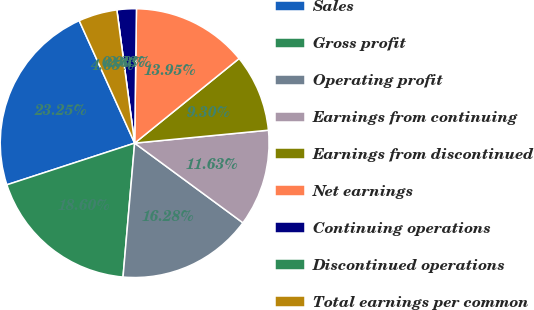<chart> <loc_0><loc_0><loc_500><loc_500><pie_chart><fcel>Sales<fcel>Gross profit<fcel>Operating profit<fcel>Earnings from continuing<fcel>Earnings from discontinued<fcel>Net earnings<fcel>Continuing operations<fcel>Discontinued operations<fcel>Total earnings per common<nl><fcel>23.25%<fcel>18.6%<fcel>16.28%<fcel>11.63%<fcel>9.3%<fcel>13.95%<fcel>2.33%<fcel>0.0%<fcel>4.65%<nl></chart> 